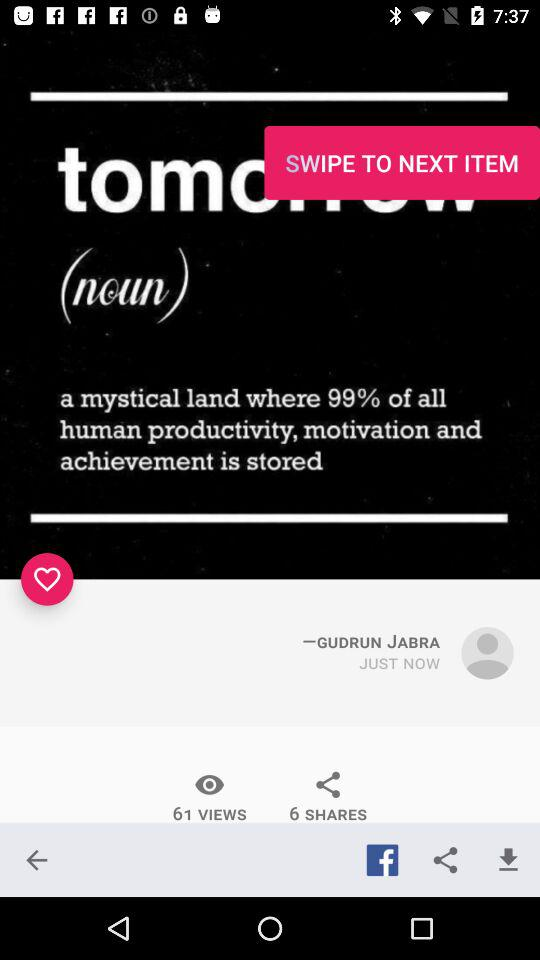How many shares are there on the post?
Answer the question using a single word or phrase. 6 